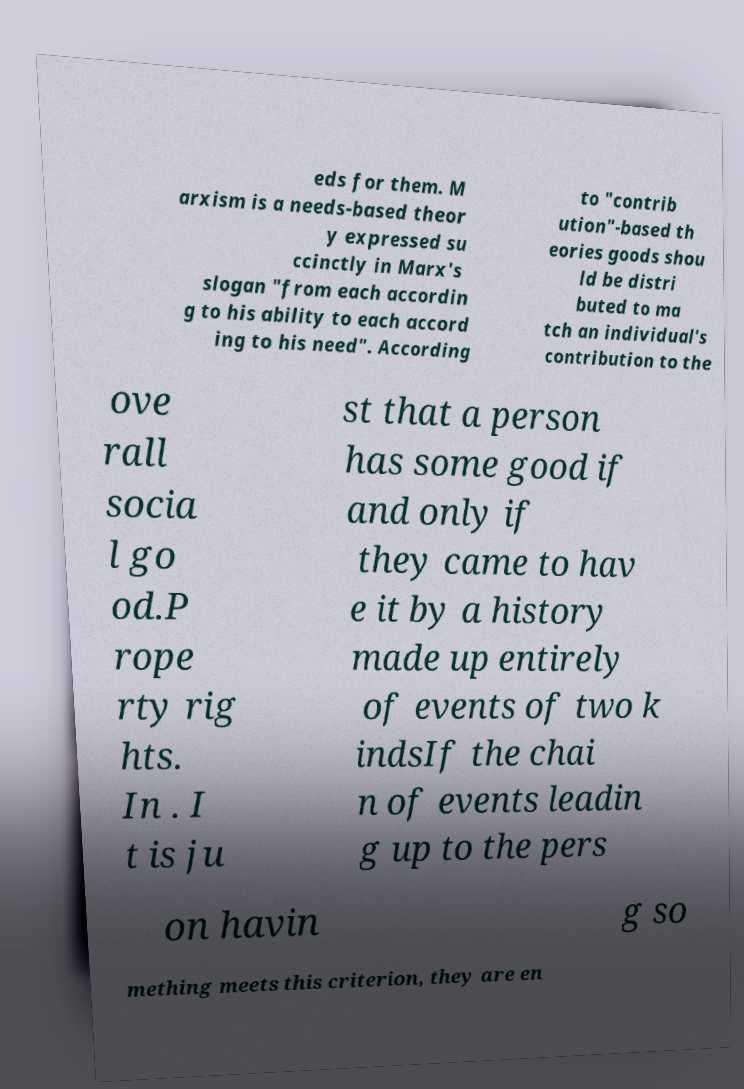Could you extract and type out the text from this image? eds for them. M arxism is a needs-based theor y expressed su ccinctly in Marx's slogan "from each accordin g to his ability to each accord ing to his need". According to "contrib ution"-based th eories goods shou ld be distri buted to ma tch an individual's contribution to the ove rall socia l go od.P rope rty rig hts. In . I t is ju st that a person has some good if and only if they came to hav e it by a history made up entirely of events of two k indsIf the chai n of events leadin g up to the pers on havin g so mething meets this criterion, they are en 